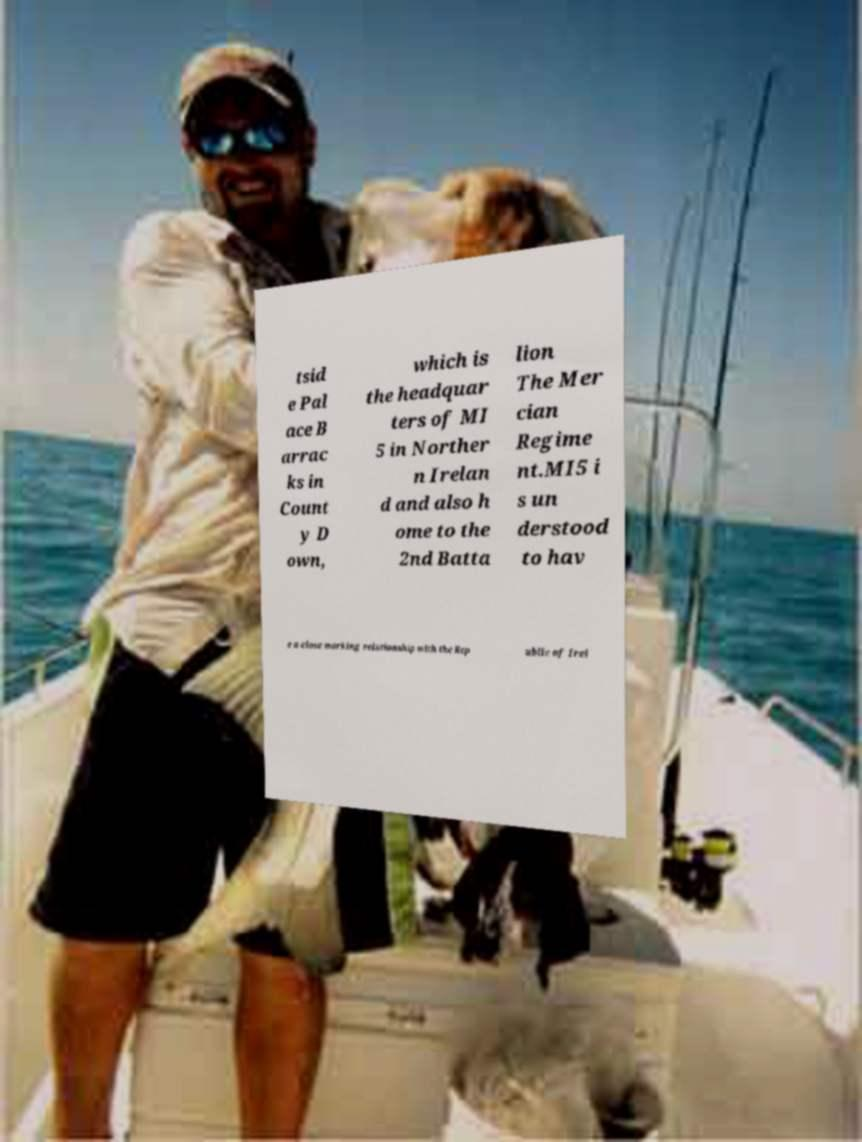Can you accurately transcribe the text from the provided image for me? tsid e Pal ace B arrac ks in Count y D own, which is the headquar ters of MI 5 in Norther n Irelan d and also h ome to the 2nd Batta lion The Mer cian Regime nt.MI5 i s un derstood to hav e a close working relationship with the Rep ublic of Irel 